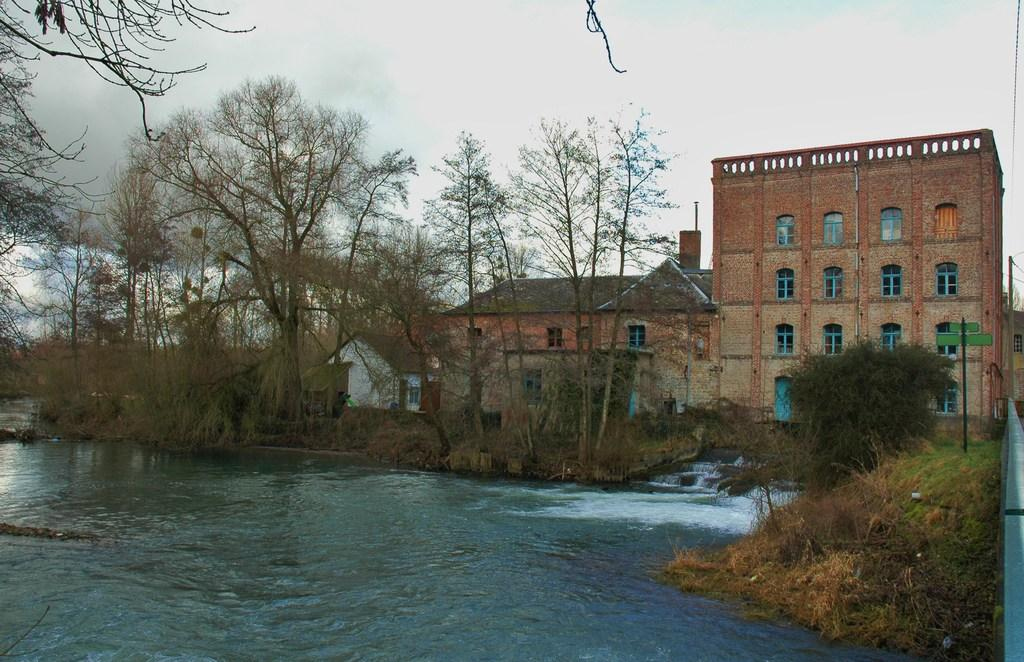What is present at the bottom of the image? There is water at the bottom of the image. What can be seen on the left side of the image? There are trees in the left side of the image. What can be seen on the right side of the image? There are trees in the right side of the image. What is located in the foreground of the image? There are trees in the foreground of the image. What is visible in the background of the image? There are buildings in the background of the image. What is visible at the top of the image? The sky is visible at the top of the image. Can you hear the toad laughing in the image? There is no toad present in the image, and therefore no such activity can be observed. 